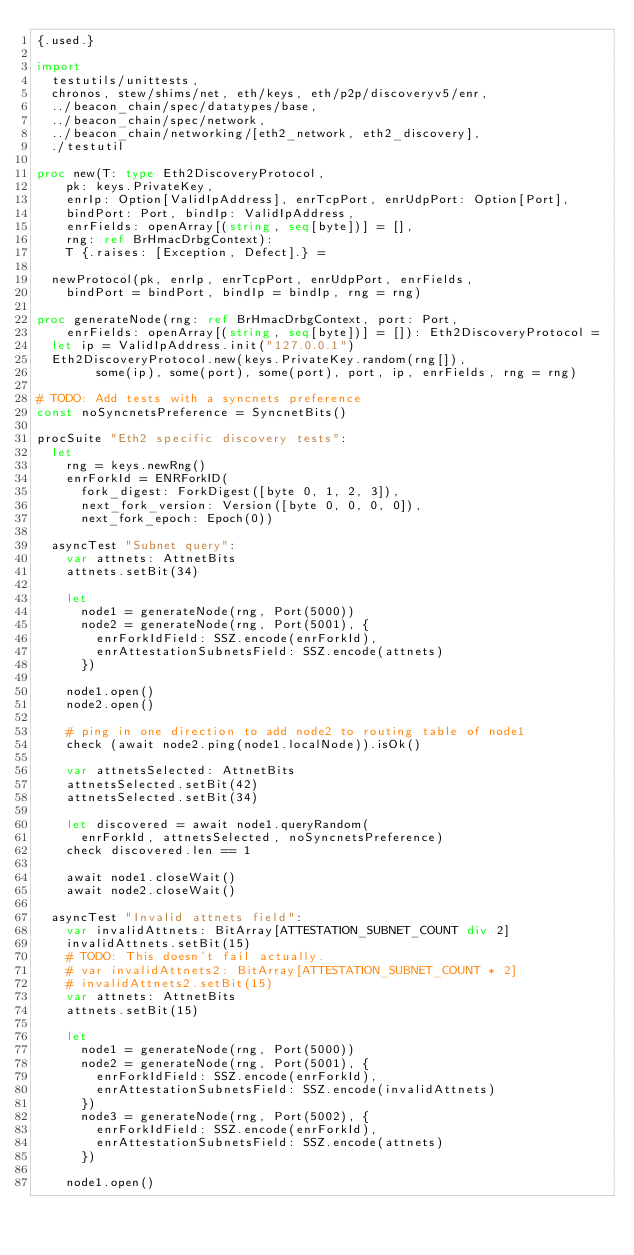Convert code to text. <code><loc_0><loc_0><loc_500><loc_500><_Nim_>{.used.}

import
  testutils/unittests,
  chronos, stew/shims/net, eth/keys, eth/p2p/discoveryv5/enr,
  ../beacon_chain/spec/datatypes/base,
  ../beacon_chain/spec/network,
  ../beacon_chain/networking/[eth2_network, eth2_discovery],
  ./testutil

proc new(T: type Eth2DiscoveryProtocol,
    pk: keys.PrivateKey,
    enrIp: Option[ValidIpAddress], enrTcpPort, enrUdpPort: Option[Port],
    bindPort: Port, bindIp: ValidIpAddress,
    enrFields: openArray[(string, seq[byte])] = [],
    rng: ref BrHmacDrbgContext):
    T {.raises: [Exception, Defect].} =

  newProtocol(pk, enrIp, enrTcpPort, enrUdpPort, enrFields,
    bindPort = bindPort, bindIp = bindIp, rng = rng)

proc generateNode(rng: ref BrHmacDrbgContext, port: Port,
    enrFields: openArray[(string, seq[byte])] = []): Eth2DiscoveryProtocol =
  let ip = ValidIpAddress.init("127.0.0.1")
  Eth2DiscoveryProtocol.new(keys.PrivateKey.random(rng[]),
        some(ip), some(port), some(port), port, ip, enrFields, rng = rng)

# TODO: Add tests with a syncnets preference
const noSyncnetsPreference = SyncnetBits()

procSuite "Eth2 specific discovery tests":
  let
    rng = keys.newRng()
    enrForkId = ENRForkID(
      fork_digest: ForkDigest([byte 0, 1, 2, 3]),
      next_fork_version: Version([byte 0, 0, 0, 0]),
      next_fork_epoch: Epoch(0))

  asyncTest "Subnet query":
    var attnets: AttnetBits
    attnets.setBit(34)

    let
      node1 = generateNode(rng, Port(5000))
      node2 = generateNode(rng, Port(5001), {
        enrForkIdField: SSZ.encode(enrForkId),
        enrAttestationSubnetsField: SSZ.encode(attnets)
      })

    node1.open()
    node2.open()

    # ping in one direction to add node2 to routing table of node1
    check (await node2.ping(node1.localNode)).isOk()

    var attnetsSelected: AttnetBits
    attnetsSelected.setBit(42)
    attnetsSelected.setBit(34)

    let discovered = await node1.queryRandom(
      enrForkId, attnetsSelected, noSyncnetsPreference)
    check discovered.len == 1

    await node1.closeWait()
    await node2.closeWait()

  asyncTest "Invalid attnets field":
    var invalidAttnets: BitArray[ATTESTATION_SUBNET_COUNT div 2]
    invalidAttnets.setBit(15)
    # TODO: This doesn't fail actually.
    # var invalidAttnets2: BitArray[ATTESTATION_SUBNET_COUNT * 2]
    # invalidAttnets2.setBit(15)
    var attnets: AttnetBits
    attnets.setBit(15)

    let
      node1 = generateNode(rng, Port(5000))
      node2 = generateNode(rng, Port(5001), {
        enrForkIdField: SSZ.encode(enrForkId),
        enrAttestationSubnetsField: SSZ.encode(invalidAttnets)
      })
      node3 = generateNode(rng, Port(5002), {
        enrForkIdField: SSZ.encode(enrForkId),
        enrAttestationSubnetsField: SSZ.encode(attnets)
      })

    node1.open()</code> 